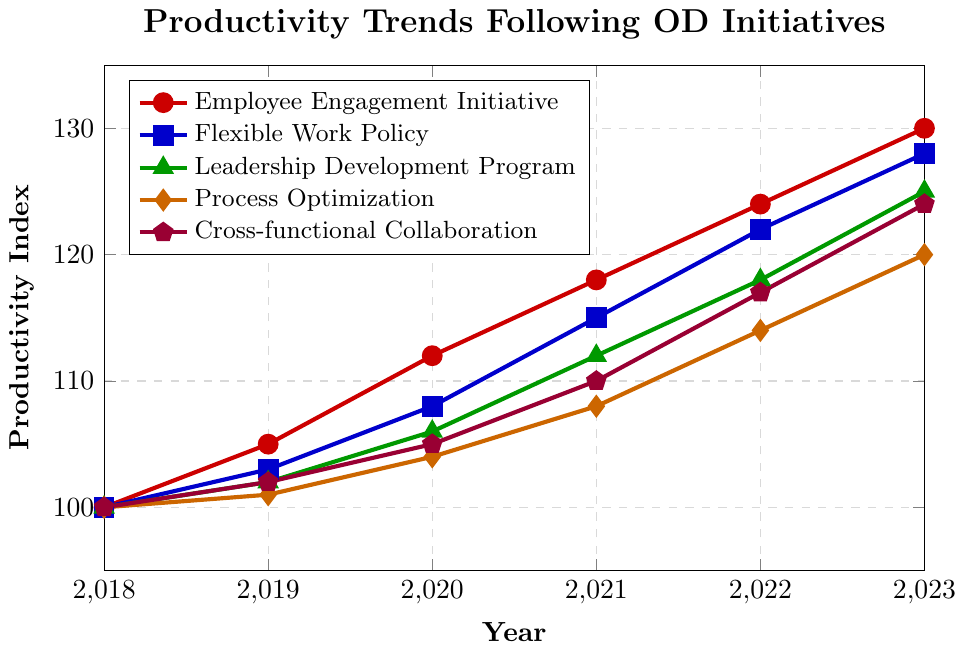What is the Productivity Index for the Employee Engagement Initiative in 2021? Locate the 'Employee Engagement Initiative' line, which is red, and move to the year 2021. The Productivity Index value is at the y-axis level of 118.
Answer: 118 Which initiative has the highest Productivity Index in 2023? Compare the Productivity Index values for all initiatives in 2023. The highest value is for the Employee Engagement Initiative at 130.
Answer: Employee Engagement Initiative How much did the Productivity Index for the Flexible Work Policy increase from 2018 to 2023? The Flexible Work Policy's index was 100 in 2018 and 128 in 2023. The increase is 128 - 100 = 28.
Answer: 28 Which initiative had the smallest increase in Productivity Index from 2018 to 2023? Calculate the increase for each initiative between 2018 and 2023 and find the smallest one:
- Employee Engagement Initiative: 130 - 100 = 30
- Flexible Work Policy: 128 - 100 = 28
- Leadership Development Program: 125 - 100 = 25
- Process Optimization: 120 - 100 = 20
- Cross-functional Collaboration: 124 - 100 = 24
The smallest increase is for Process Optimization.
Answer: Process Optimization Between which two consecutive years did the Leadership Development Program show the largest increase in Productivity Index? Check the year-to-year differences for the Leadership Development Program:
- 2018 to 2019: 102 - 100 = 2
- 2019 to 2020: 106 - 102 = 4
- 2020 to 2021: 112 - 106 = 6
- 2021 to 2022: 118 - 112 = 6
- 2022 to 2023: 125 - 118 = 7
The largest increase occurred between 2022 and 2023.
Answer: 2022 to 2023 What is the average Productivity Index for the Cross-functional Collaboration initiative over the 6 years? Sum the Productivity Index values for Cross-functional Collaboration from 2018 to 2023 and divide by the number of years:
(100 + 102 + 105 + 110 + 117 + 124) / 6 = 658 / 6 = 109.67.
Answer: 109.67 In which year did the Process Optimization initiative first reach a Productivity Index above 110? By inspecting the Process Optimization line, the first year it crosses 110 is in 2022.
Answer: 2022 How does the trend of the Employee Engagement Initiative compare to that of the Leadership Development Program from 2018 to 2023? The Employee Engagement Initiative line is consistently higher and shows a steady increase. The Leadership Development Program also increases steadily but at a slightly slower rate, resulting in a lower final value in 2023.
Answer: Employee Engagement Initiative has a higher and steeper increase What is the difference in the Productivity Index between the Flexible Work Policy and Process Optimization in 2020? Find the values in 2020:
- Flexible Work Policy: 108
- Process Optimization: 104
The difference is 108 - 104 = 4.
Answer: 4 